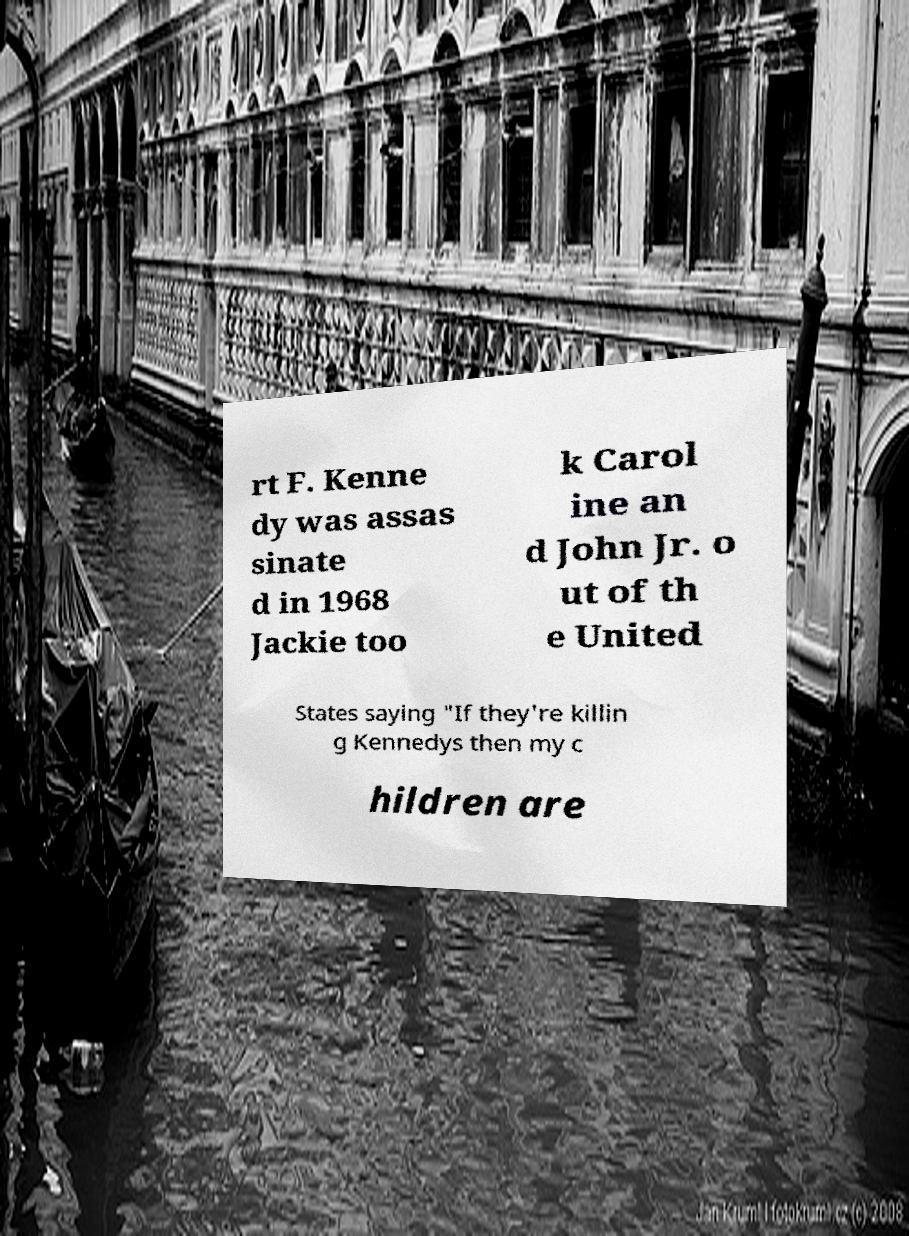Can you read and provide the text displayed in the image?This photo seems to have some interesting text. Can you extract and type it out for me? rt F. Kenne dy was assas sinate d in 1968 Jackie too k Carol ine an d John Jr. o ut of th e United States saying "If they're killin g Kennedys then my c hildren are 